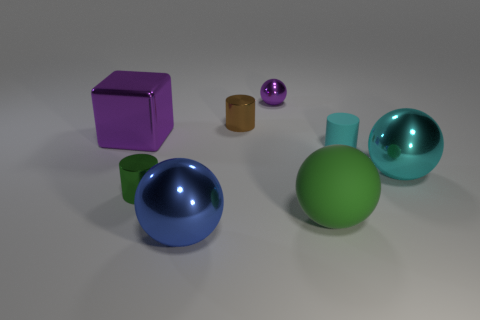There is a big shiny thing that is in front of the tiny green thing; is it the same color as the metallic cylinder that is in front of the large purple block?
Offer a very short reply. No. How many tiny objects are both to the left of the small cyan cylinder and behind the large cyan metal ball?
Your answer should be very brief. 2. The cyan object that is made of the same material as the large blue sphere is what size?
Offer a terse response. Large. The blue object is what size?
Your response must be concise. Large. What is the material of the tiny purple ball?
Offer a very short reply. Metal. Is the size of the brown metallic cylinder in front of the purple shiny ball the same as the small purple metallic sphere?
Provide a short and direct response. Yes. What number of objects are large blue spheres or tiny cylinders?
Provide a short and direct response. 4. The tiny object that is the same color as the large metallic cube is what shape?
Your response must be concise. Sphere. What is the size of the metallic object that is on the left side of the blue thing and right of the big purple metal cube?
Your answer should be very brief. Small. How many green cylinders are there?
Keep it short and to the point. 1. 